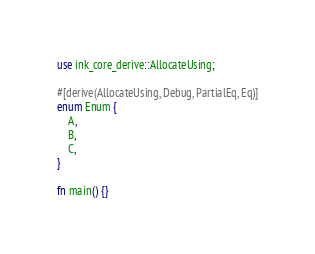Convert code to text. <code><loc_0><loc_0><loc_500><loc_500><_Rust_>use ink_core_derive::AllocateUsing;

#[derive(AllocateUsing, Debug, PartialEq, Eq)]
enum Enum {
    A,
    B,
    C,
}

fn main() {}
</code> 